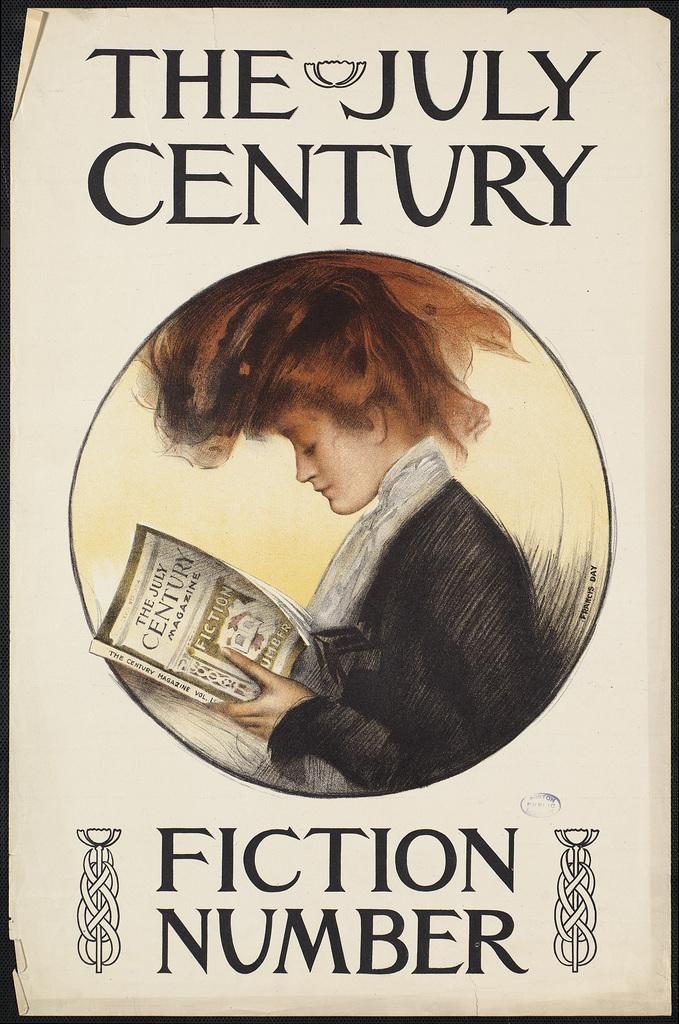<image>
Summarize the visual content of the image. A fistion number book titled The July Century 